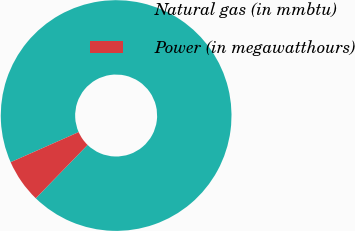Convert chart. <chart><loc_0><loc_0><loc_500><loc_500><pie_chart><fcel>Natural gas (in mmbtu)<fcel>Power (in megawatthours)<nl><fcel>93.9%<fcel>6.1%<nl></chart> 